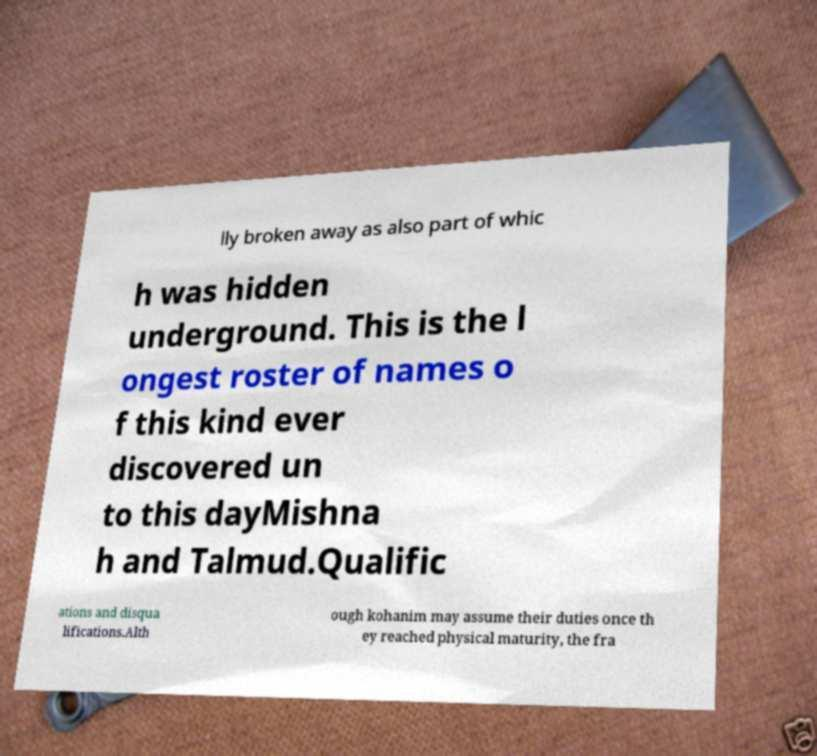Can you read and provide the text displayed in the image?This photo seems to have some interesting text. Can you extract and type it out for me? lly broken away as also part of whic h was hidden underground. This is the l ongest roster of names o f this kind ever discovered un to this dayMishna h and Talmud.Qualific ations and disqua lifications.Alth ough kohanim may assume their duties once th ey reached physical maturity, the fra 